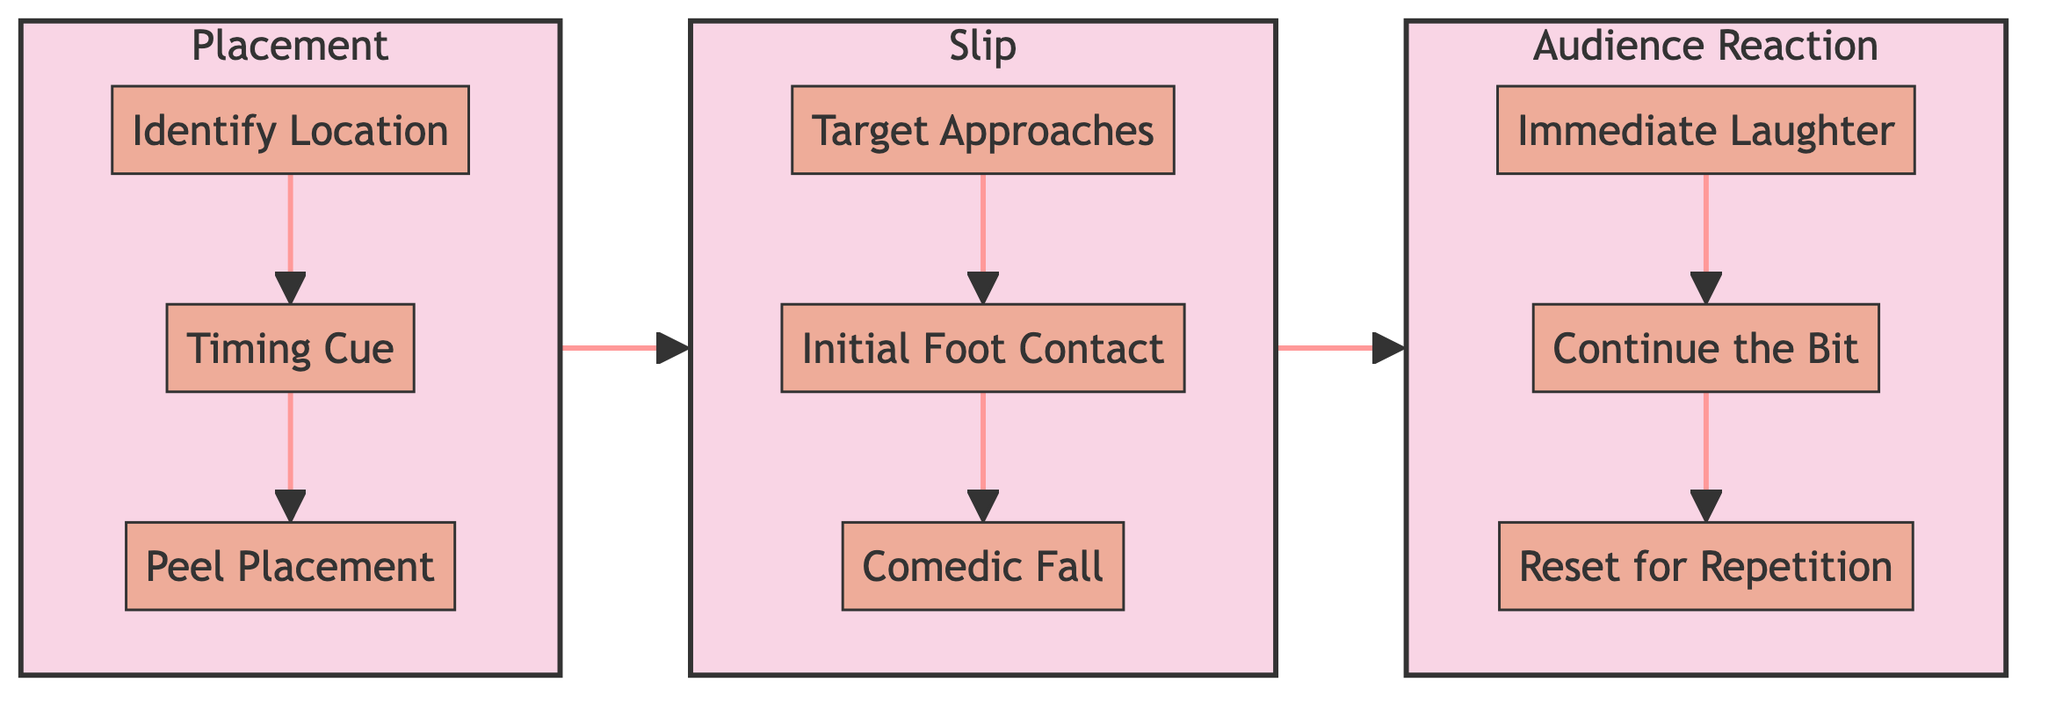What are the three main stages of the banana peel bit? The diagram clearly shows three main stages: Placement, Slip, and Audience Reaction. These are titles of the subgraphs that encapsulate the comedic sequence.
Answer: Placement, Slip, Audience Reaction How many steps are there in the Placement stage? In the Placement stage, there are three distinct steps outlined: Identify Location, Timing Cue, and Peel Placement. By counting these, we find the total is three steps.
Answer: 3 What is the last step in the Slip stage? The final step in the Slip stage is Comedic Fall, which is the third step within this subgraph detailing the slip's execution in a physically comedic manner.
Answer: Comedic Fall Which step follows Immediate Laughter in the Audience Reaction stage? When following the Immediate Laughter step, the next step in the flowchart is Continue the Bit, indicating what occurs immediately after the audience's laughter.
Answer: Continue the Bit What is the first step of the Audience Reaction stage? The initial step in the Audience Reaction stage is Immediate Laughter, which happens right after the comedic fall, highlighting the audience's response.
Answer: Immediate Laughter Is Timing Cue linked to another step? If so, which one? Timing Cue is linked to the next step in the Placement stage, which is Peel Placement. This indicates that Timing Cue precedes and connects to Peel Placement.
Answer: Peel Placement What is the order of steps in the Slip stage? The steps in the Slip stage occur in the following order: Target Approaches, Initial Foot Contact, and Comedic Fall. Each step flows sequentially leading to the slip's climax.
Answer: Target Approaches, Initial Foot Contact, Comedic Fall How many total steps are in the entire flowchart? Adding the steps from each stage: Placement has three steps, Slip has three steps, and Audience Reaction has three steps, giving a total of nine steps across all stages.
Answer: 9 What connects the Placement stage to the Slip stage? The Placement stage connects to the Slip stage through the logical progression of the comedy bit, indicating that after Placement, the next action is the Slip.
Answer: Slip 